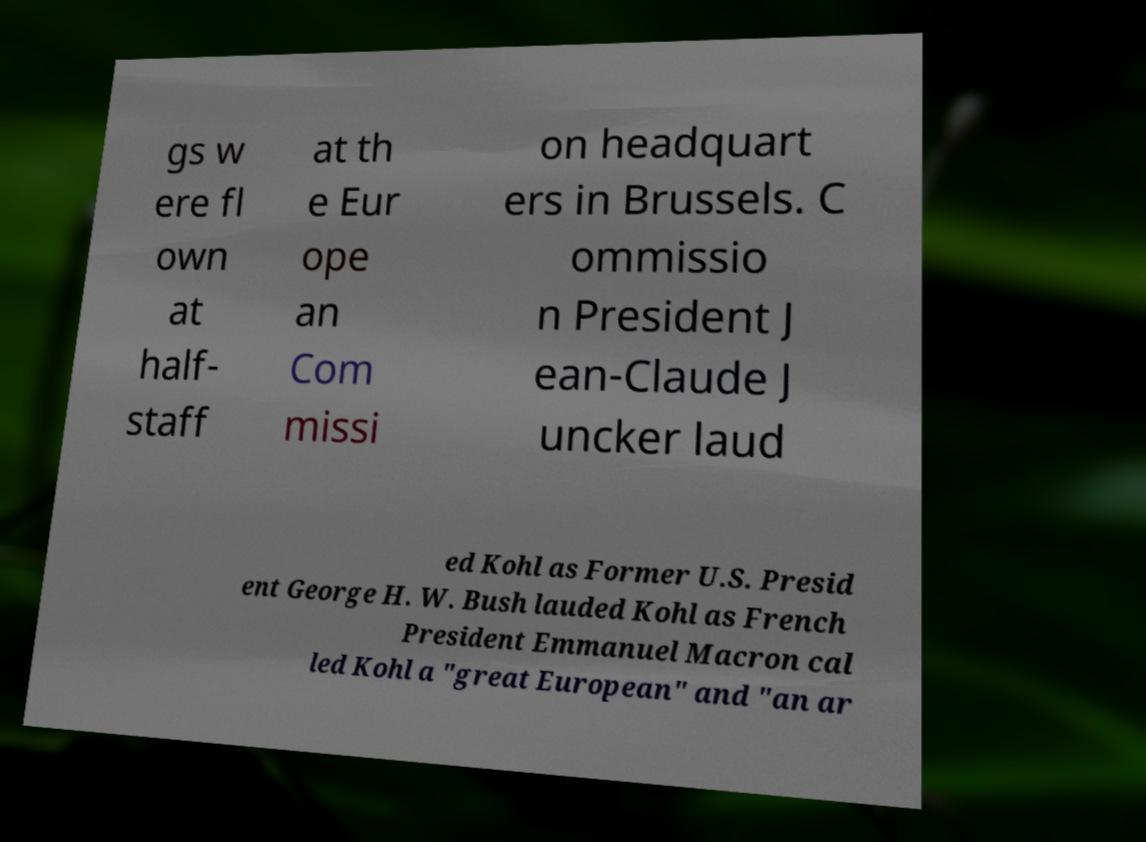There's text embedded in this image that I need extracted. Can you transcribe it verbatim? gs w ere fl own at half- staff at th e Eur ope an Com missi on headquart ers in Brussels. C ommissio n President J ean-Claude J uncker laud ed Kohl as Former U.S. Presid ent George H. W. Bush lauded Kohl as French President Emmanuel Macron cal led Kohl a "great European" and "an ar 